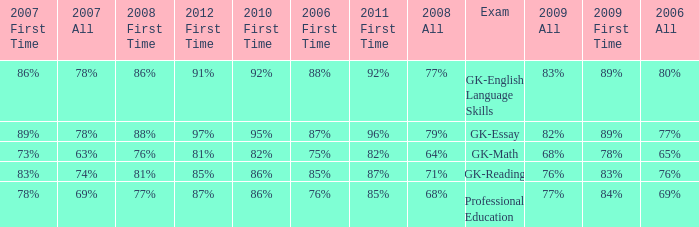What is the percentage for all in 2008 when all in 2007 was 69%? 68%. 